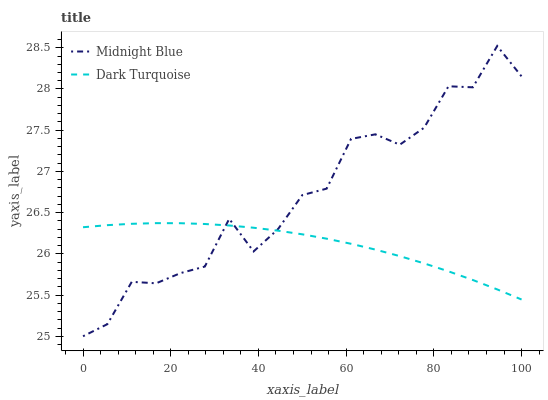Does Dark Turquoise have the minimum area under the curve?
Answer yes or no. Yes. Does Midnight Blue have the maximum area under the curve?
Answer yes or no. Yes. Does Midnight Blue have the minimum area under the curve?
Answer yes or no. No. Is Dark Turquoise the smoothest?
Answer yes or no. Yes. Is Midnight Blue the roughest?
Answer yes or no. Yes. Is Midnight Blue the smoothest?
Answer yes or no. No. Does Midnight Blue have the highest value?
Answer yes or no. Yes. Does Dark Turquoise intersect Midnight Blue?
Answer yes or no. Yes. Is Dark Turquoise less than Midnight Blue?
Answer yes or no. No. Is Dark Turquoise greater than Midnight Blue?
Answer yes or no. No. 